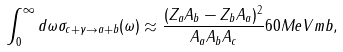Convert formula to latex. <formula><loc_0><loc_0><loc_500><loc_500>\int _ { 0 } ^ { \infty } d \omega \sigma _ { c + \gamma \rightarrow a + b } ( \omega ) \approx \frac { ( Z _ { a } A _ { b } - Z _ { b } A _ { a } ) ^ { 2 } } { A _ { a } A _ { b } A _ { c } } 6 0 M e V m b ,</formula> 